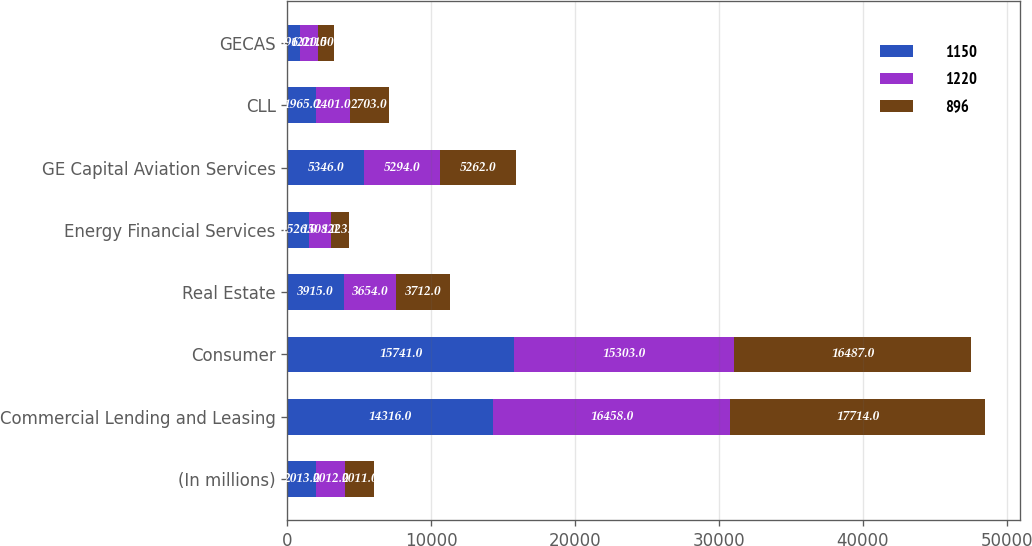Convert chart. <chart><loc_0><loc_0><loc_500><loc_500><stacked_bar_chart><ecel><fcel>(In millions)<fcel>Commercial Lending and Leasing<fcel>Consumer<fcel>Real Estate<fcel>Energy Financial Services<fcel>GE Capital Aviation Services<fcel>CLL<fcel>GECAS<nl><fcel>1150<fcel>2013<fcel>14316<fcel>15741<fcel>3915<fcel>1526<fcel>5346<fcel>1965<fcel>896<nl><fcel>1220<fcel>2012<fcel>16458<fcel>15303<fcel>3654<fcel>1508<fcel>5294<fcel>2401<fcel>1220<nl><fcel>896<fcel>2011<fcel>17714<fcel>16487<fcel>3712<fcel>1223<fcel>5262<fcel>2703<fcel>1150<nl></chart> 